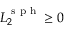Convert formula to latex. <formula><loc_0><loc_0><loc_500><loc_500>L _ { 2 } ^ { s p h } \geq 0</formula> 